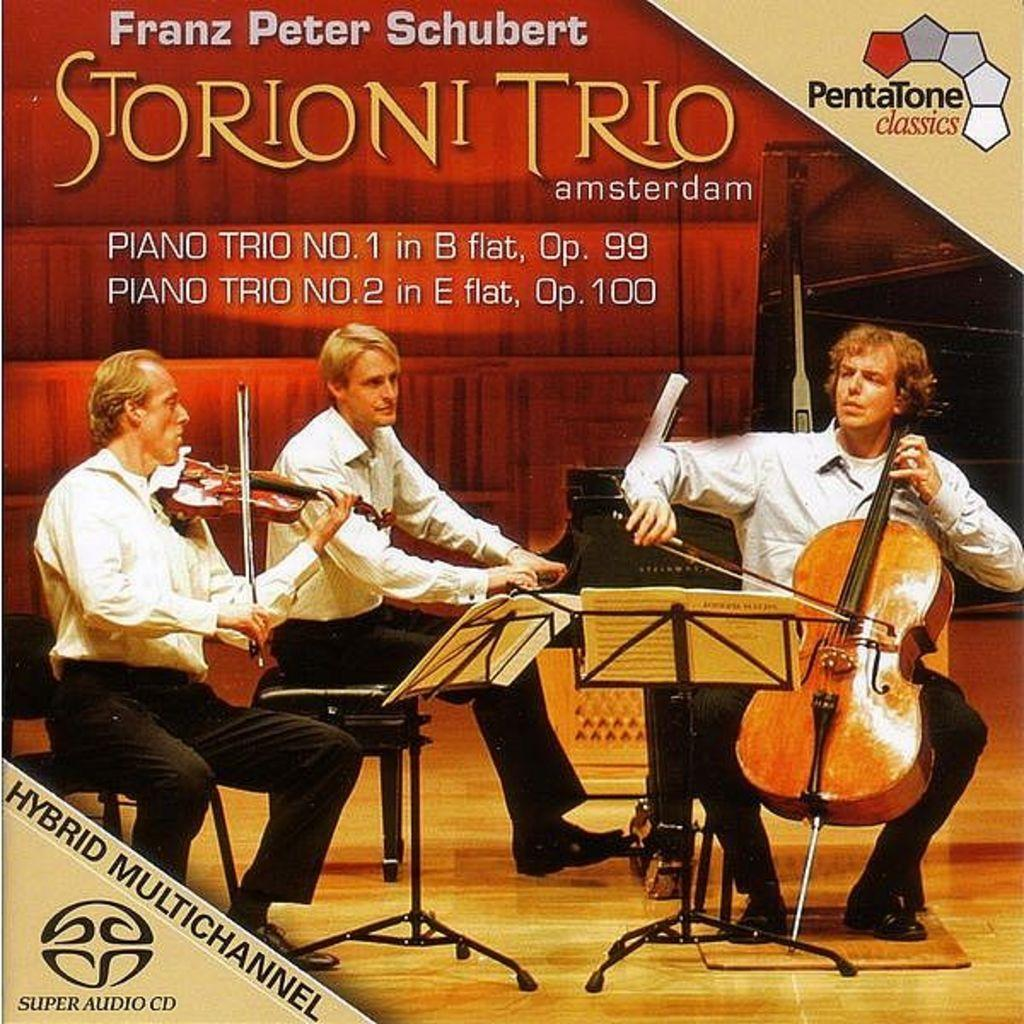How many people are in the image? There are three persons in the image. What are the persons doing in the image? The persons are playing musical instruments. What is the position of the persons in the image? The persons are sitting on a chair. What can be seen in the background of the image? The background of the image is water. What time of day is it in the image, considering the presence of a pencil? There is no pencil present in the image, so it cannot be used to determine the time of day. 